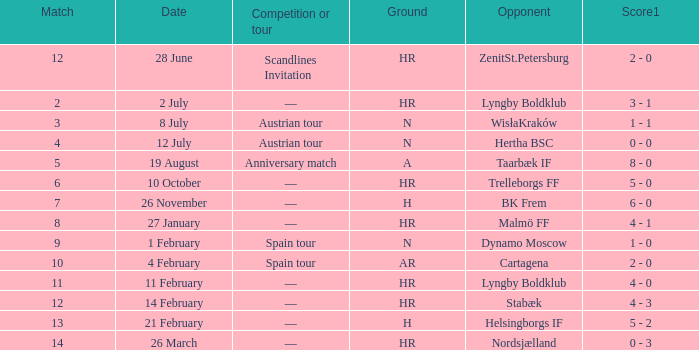In which competition or tour was nordsjælland the opponent with a hr Ground? —. Help me parse the entirety of this table. {'header': ['Match', 'Date', 'Competition or tour', 'Ground', 'Opponent', 'Score1'], 'rows': [['12', '28 June', 'Scandlines Invitation', 'HR', 'ZenitSt.Petersburg', '2 - 0'], ['2', '2 July', '—', 'HR', 'Lyngby Boldklub', '3 - 1'], ['3', '8 July', 'Austrian tour', 'N', 'WisłaKraków', '1 - 1'], ['4', '12 July', 'Austrian tour', 'N', 'Hertha BSC', '0 - 0'], ['5', '19 August', 'Anniversary match', 'A', 'Taarbæk IF', '8 - 0'], ['6', '10 October', '—', 'HR', 'Trelleborgs FF', '5 - 0'], ['7', '26 November', '—', 'H', 'BK Frem', '6 - 0'], ['8', '27 January', '—', 'HR', 'Malmö FF', '4 - 1'], ['9', '1 February', 'Spain tour', 'N', 'Dynamo Moscow', '1 - 0'], ['10', '4 February', 'Spain tour', 'AR', 'Cartagena', '2 - 0'], ['11', '11 February', '—', 'HR', 'Lyngby Boldklub', '4 - 0'], ['12', '14 February', '—', 'HR', 'Stabæk', '4 - 3'], ['13', '21 February', '—', 'H', 'Helsingborgs IF', '5 - 2'], ['14', '26 March', '—', 'HR', 'Nordsjælland', '0 - 3']]} 